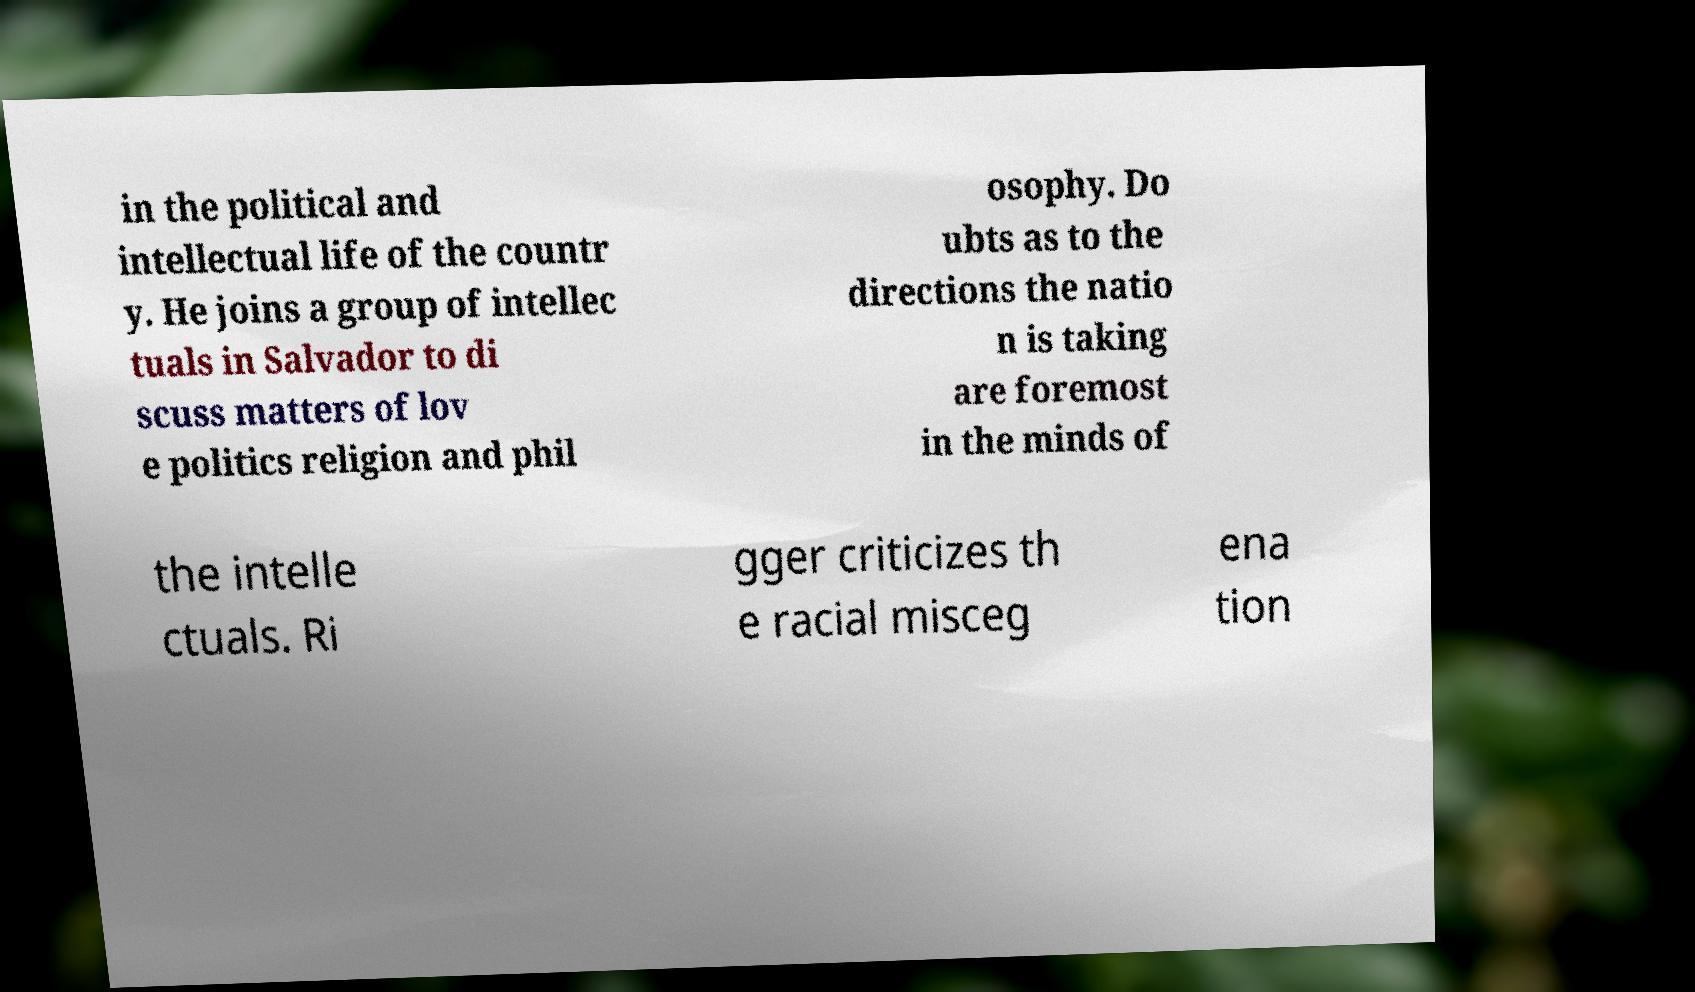What messages or text are displayed in this image? I need them in a readable, typed format. in the political and intellectual life of the countr y. He joins a group of intellec tuals in Salvador to di scuss matters of lov e politics religion and phil osophy. Do ubts as to the directions the natio n is taking are foremost in the minds of the intelle ctuals. Ri gger criticizes th e racial misceg ena tion 